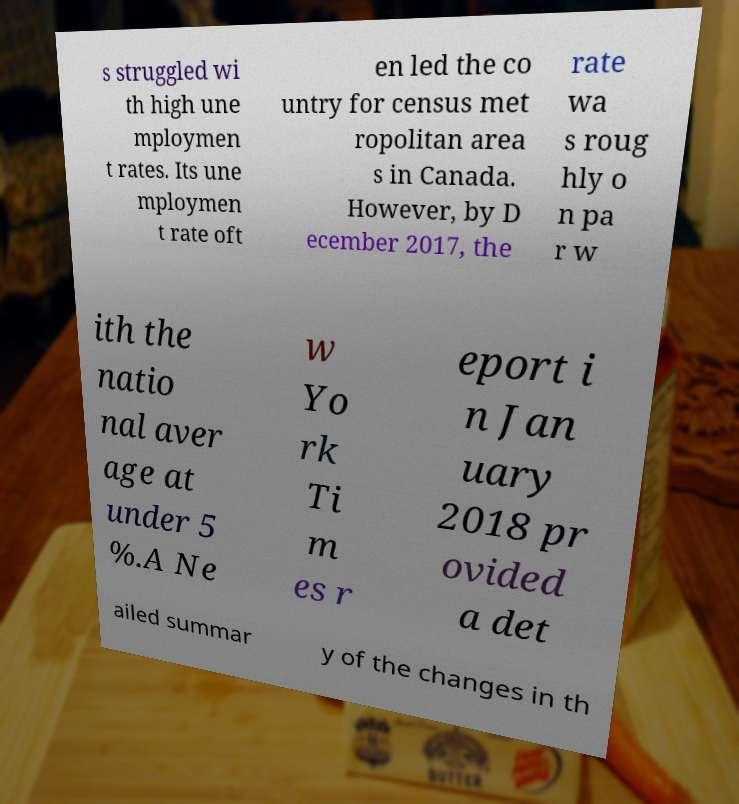I need the written content from this picture converted into text. Can you do that? s struggled wi th high une mploymen t rates. Its une mploymen t rate oft en led the co untry for census met ropolitan area s in Canada. However, by D ecember 2017, the rate wa s roug hly o n pa r w ith the natio nal aver age at under 5 %.A Ne w Yo rk Ti m es r eport i n Jan uary 2018 pr ovided a det ailed summar y of the changes in th 